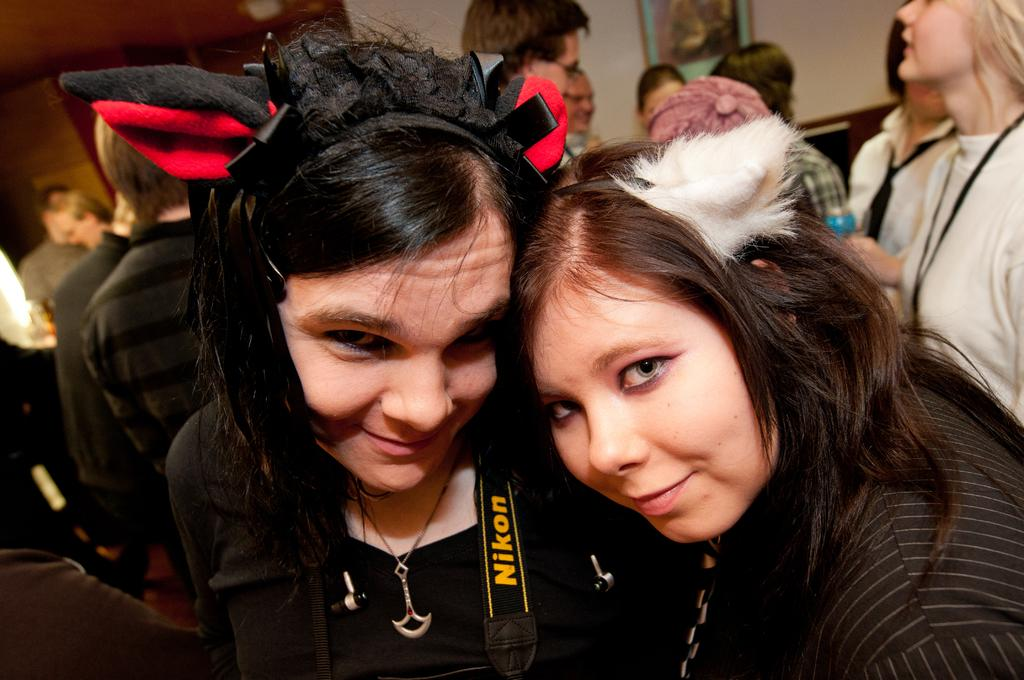What is the main subject of the image? The main subject of the image is a group of people. Can you describe the appearance of the people in the image? The people in the image are wearing clothes. How many persons are in the middle of the image? There are two persons in the middle of the image. What distinguishes the two persons in the middle from the rest of the group? The two persons in the middle are wearing bunny ears. What is the total wealth of the group of people in the image? There is no information about the wealth of the people in the image, so it cannot be determined. 